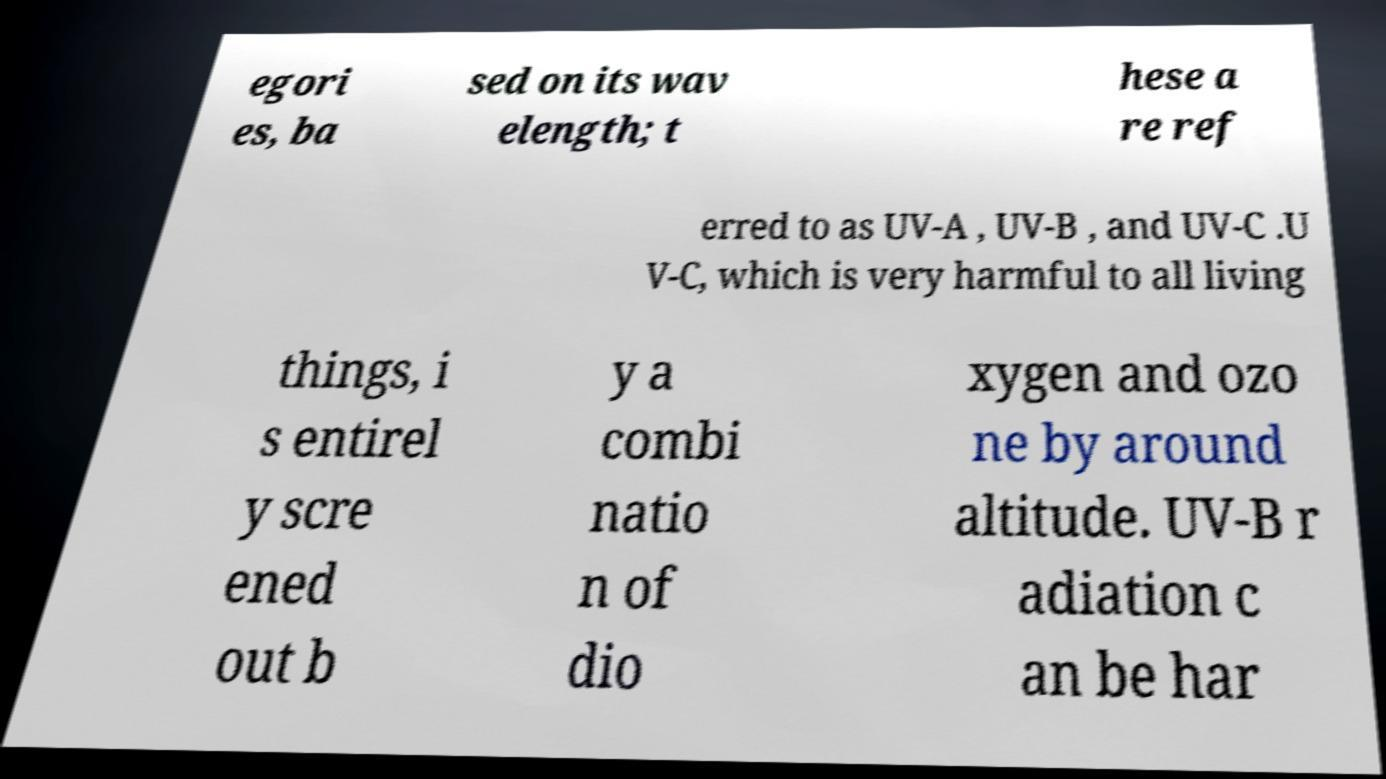For documentation purposes, I need the text within this image transcribed. Could you provide that? egori es, ba sed on its wav elength; t hese a re ref erred to as UV-A , UV-B , and UV-C .U V-C, which is very harmful to all living things, i s entirel y scre ened out b y a combi natio n of dio xygen and ozo ne by around altitude. UV-B r adiation c an be har 